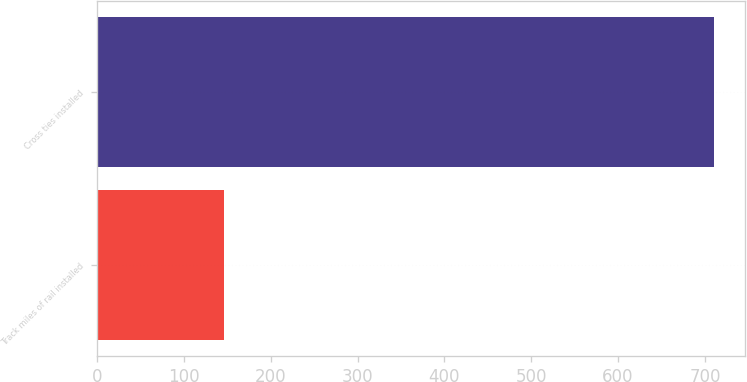Convert chart. <chart><loc_0><loc_0><loc_500><loc_500><bar_chart><fcel>Track miles of rail installed<fcel>Cross ties installed<nl><fcel>146<fcel>711<nl></chart> 